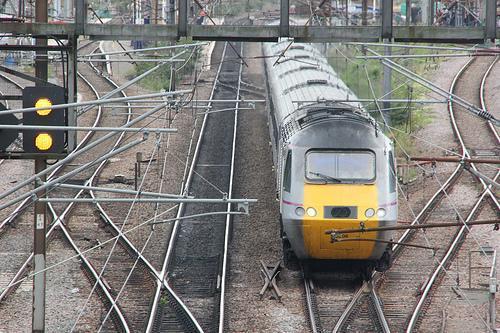How many trains are there?
Give a very brief answer. 1. 